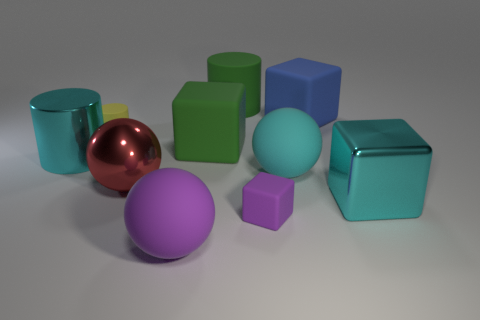Subtract 1 blocks. How many blocks are left? 3 Subtract all rubber spheres. How many spheres are left? 1 Subtract all blue cubes. How many cubes are left? 3 Subtract all cylinders. How many objects are left? 7 Subtract all yellow blocks. Subtract all red cylinders. How many blocks are left? 4 Subtract all cyan matte objects. Subtract all big red metal things. How many objects are left? 8 Add 1 large red spheres. How many large red spheres are left? 2 Add 8 matte cylinders. How many matte cylinders exist? 10 Subtract 0 red cylinders. How many objects are left? 10 